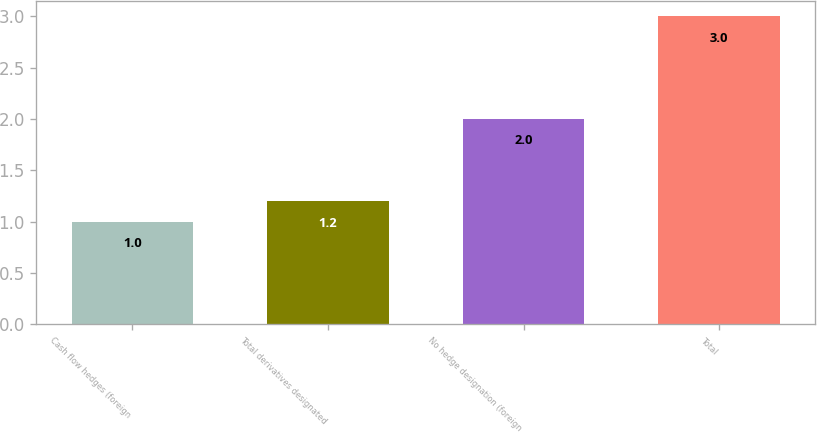Convert chart. <chart><loc_0><loc_0><loc_500><loc_500><bar_chart><fcel>Cash flow hedges (foreign<fcel>Total derivatives designated<fcel>No hedge designation (foreign<fcel>Total<nl><fcel>1<fcel>1.2<fcel>2<fcel>3<nl></chart> 